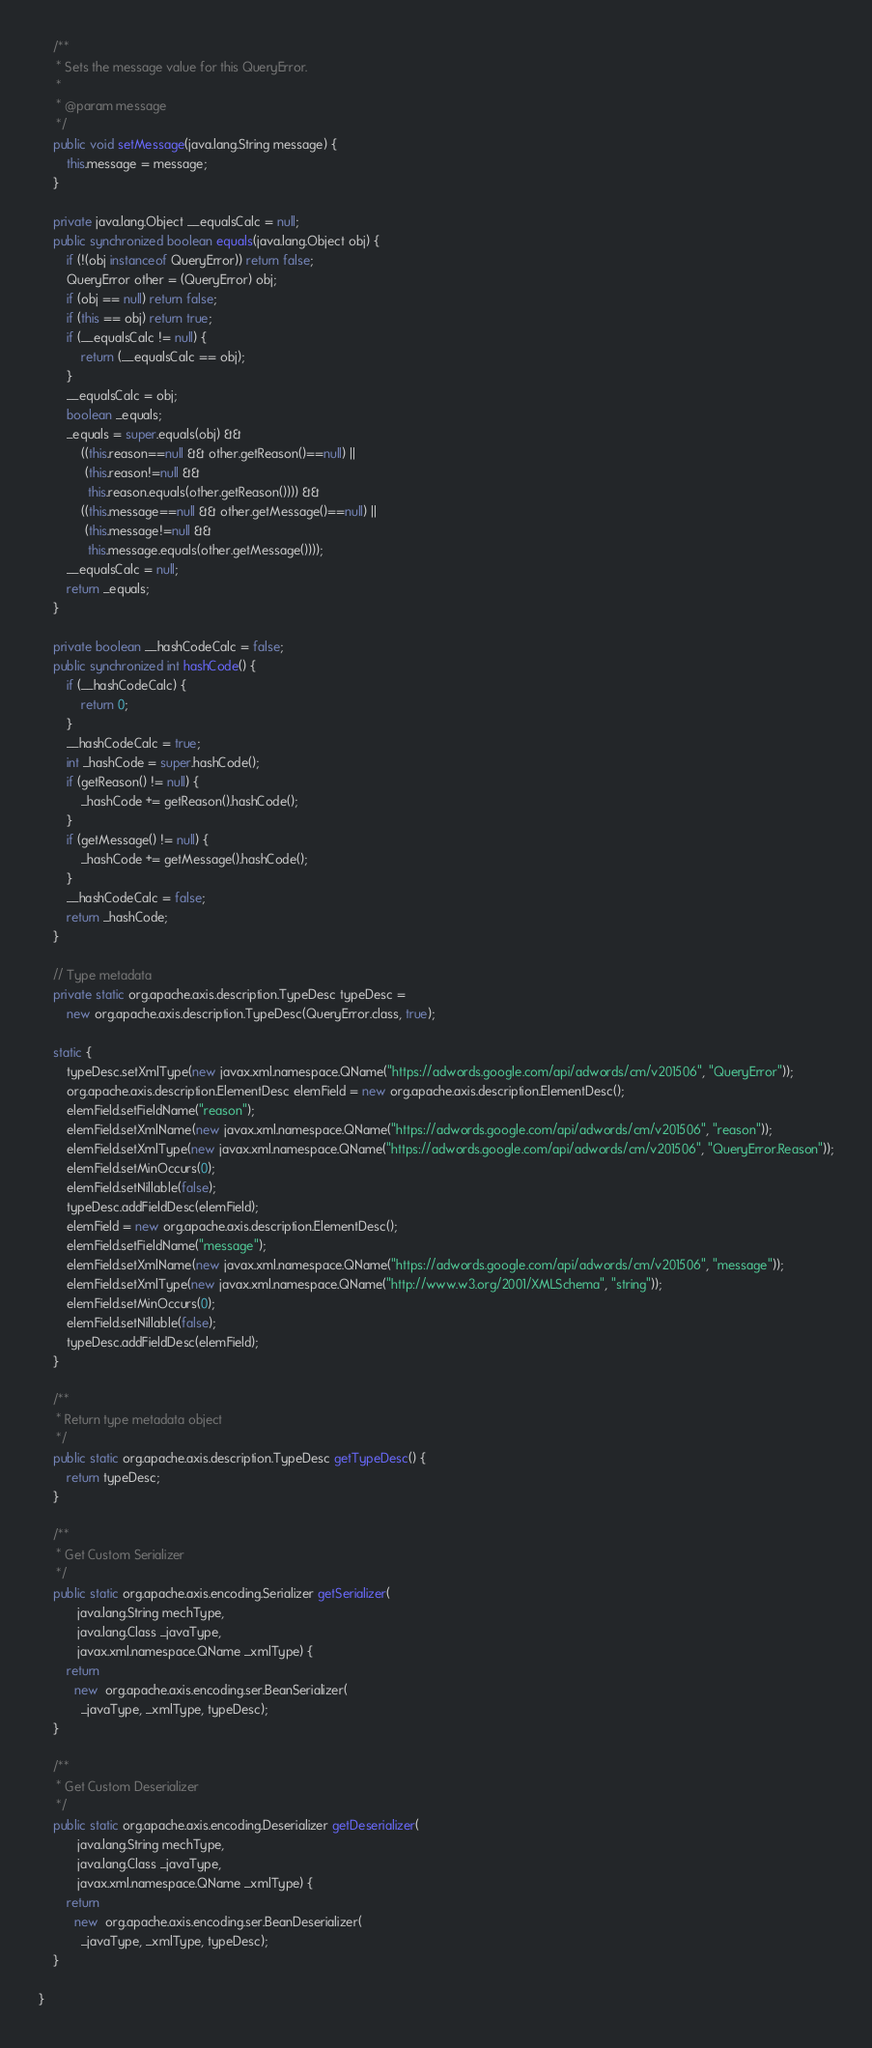Convert code to text. <code><loc_0><loc_0><loc_500><loc_500><_Java_>
    /**
     * Sets the message value for this QueryError.
     * 
     * @param message
     */
    public void setMessage(java.lang.String message) {
        this.message = message;
    }

    private java.lang.Object __equalsCalc = null;
    public synchronized boolean equals(java.lang.Object obj) {
        if (!(obj instanceof QueryError)) return false;
        QueryError other = (QueryError) obj;
        if (obj == null) return false;
        if (this == obj) return true;
        if (__equalsCalc != null) {
            return (__equalsCalc == obj);
        }
        __equalsCalc = obj;
        boolean _equals;
        _equals = super.equals(obj) && 
            ((this.reason==null && other.getReason()==null) || 
             (this.reason!=null &&
              this.reason.equals(other.getReason()))) &&
            ((this.message==null && other.getMessage()==null) || 
             (this.message!=null &&
              this.message.equals(other.getMessage())));
        __equalsCalc = null;
        return _equals;
    }

    private boolean __hashCodeCalc = false;
    public synchronized int hashCode() {
        if (__hashCodeCalc) {
            return 0;
        }
        __hashCodeCalc = true;
        int _hashCode = super.hashCode();
        if (getReason() != null) {
            _hashCode += getReason().hashCode();
        }
        if (getMessage() != null) {
            _hashCode += getMessage().hashCode();
        }
        __hashCodeCalc = false;
        return _hashCode;
    }

    // Type metadata
    private static org.apache.axis.description.TypeDesc typeDesc =
        new org.apache.axis.description.TypeDesc(QueryError.class, true);

    static {
        typeDesc.setXmlType(new javax.xml.namespace.QName("https://adwords.google.com/api/adwords/cm/v201506", "QueryError"));
        org.apache.axis.description.ElementDesc elemField = new org.apache.axis.description.ElementDesc();
        elemField.setFieldName("reason");
        elemField.setXmlName(new javax.xml.namespace.QName("https://adwords.google.com/api/adwords/cm/v201506", "reason"));
        elemField.setXmlType(new javax.xml.namespace.QName("https://adwords.google.com/api/adwords/cm/v201506", "QueryError.Reason"));
        elemField.setMinOccurs(0);
        elemField.setNillable(false);
        typeDesc.addFieldDesc(elemField);
        elemField = new org.apache.axis.description.ElementDesc();
        elemField.setFieldName("message");
        elemField.setXmlName(new javax.xml.namespace.QName("https://adwords.google.com/api/adwords/cm/v201506", "message"));
        elemField.setXmlType(new javax.xml.namespace.QName("http://www.w3.org/2001/XMLSchema", "string"));
        elemField.setMinOccurs(0);
        elemField.setNillable(false);
        typeDesc.addFieldDesc(elemField);
    }

    /**
     * Return type metadata object
     */
    public static org.apache.axis.description.TypeDesc getTypeDesc() {
        return typeDesc;
    }

    /**
     * Get Custom Serializer
     */
    public static org.apache.axis.encoding.Serializer getSerializer(
           java.lang.String mechType, 
           java.lang.Class _javaType,  
           javax.xml.namespace.QName _xmlType) {
        return 
          new  org.apache.axis.encoding.ser.BeanSerializer(
            _javaType, _xmlType, typeDesc);
    }

    /**
     * Get Custom Deserializer
     */
    public static org.apache.axis.encoding.Deserializer getDeserializer(
           java.lang.String mechType, 
           java.lang.Class _javaType,  
           javax.xml.namespace.QName _xmlType) {
        return 
          new  org.apache.axis.encoding.ser.BeanDeserializer(
            _javaType, _xmlType, typeDesc);
    }

}
</code> 